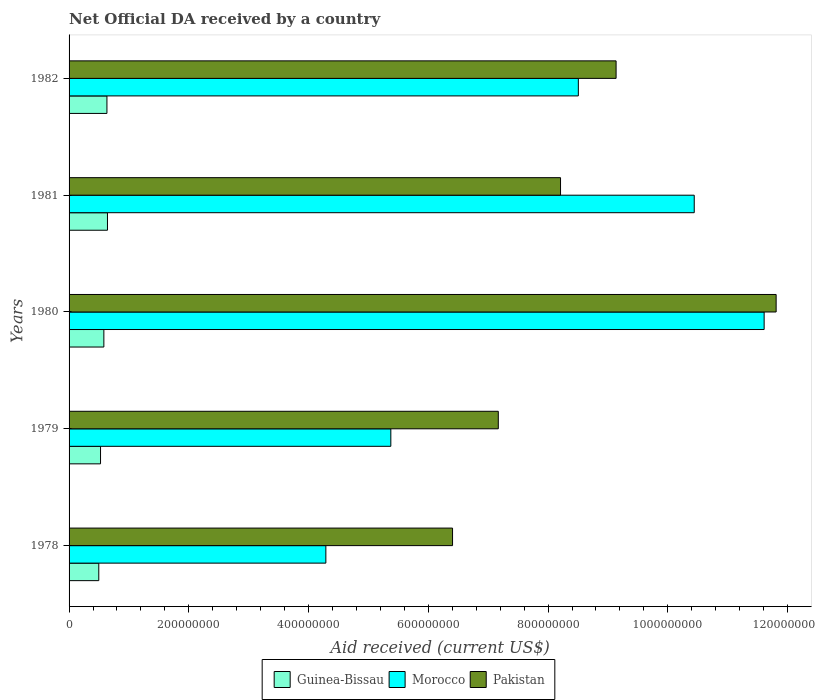How many groups of bars are there?
Your response must be concise. 5. What is the label of the 4th group of bars from the top?
Provide a short and direct response. 1979. In how many cases, is the number of bars for a given year not equal to the number of legend labels?
Make the answer very short. 0. What is the net official development assistance aid received in Guinea-Bissau in 1980?
Provide a succinct answer. 5.81e+07. Across all years, what is the maximum net official development assistance aid received in Guinea-Bissau?
Offer a terse response. 6.41e+07. Across all years, what is the minimum net official development assistance aid received in Morocco?
Provide a short and direct response. 4.29e+08. In which year was the net official development assistance aid received in Guinea-Bissau minimum?
Provide a succinct answer. 1978. What is the total net official development assistance aid received in Pakistan in the graph?
Offer a terse response. 4.27e+09. What is the difference between the net official development assistance aid received in Guinea-Bissau in 1979 and that in 1981?
Make the answer very short. -1.16e+07. What is the difference between the net official development assistance aid received in Pakistan in 1979 and the net official development assistance aid received in Morocco in 1980?
Provide a short and direct response. -4.44e+08. What is the average net official development assistance aid received in Pakistan per year?
Offer a terse response. 8.55e+08. In the year 1981, what is the difference between the net official development assistance aid received in Guinea-Bissau and net official development assistance aid received in Pakistan?
Your response must be concise. -7.57e+08. What is the ratio of the net official development assistance aid received in Morocco in 1978 to that in 1980?
Give a very brief answer. 0.37. Is the difference between the net official development assistance aid received in Guinea-Bissau in 1978 and 1979 greater than the difference between the net official development assistance aid received in Pakistan in 1978 and 1979?
Make the answer very short. Yes. What is the difference between the highest and the second highest net official development assistance aid received in Pakistan?
Keep it short and to the point. 2.67e+08. What is the difference between the highest and the lowest net official development assistance aid received in Guinea-Bissau?
Your answer should be compact. 1.45e+07. In how many years, is the net official development assistance aid received in Guinea-Bissau greater than the average net official development assistance aid received in Guinea-Bissau taken over all years?
Your answer should be very brief. 3. What does the 2nd bar from the top in 1979 represents?
Your response must be concise. Morocco. What does the 1st bar from the bottom in 1978 represents?
Offer a very short reply. Guinea-Bissau. Is it the case that in every year, the sum of the net official development assistance aid received in Morocco and net official development assistance aid received in Guinea-Bissau is greater than the net official development assistance aid received in Pakistan?
Keep it short and to the point. No. How many bars are there?
Give a very brief answer. 15. Are all the bars in the graph horizontal?
Ensure brevity in your answer.  Yes. How many years are there in the graph?
Give a very brief answer. 5. Are the values on the major ticks of X-axis written in scientific E-notation?
Ensure brevity in your answer.  No. Does the graph contain grids?
Offer a very short reply. No. How many legend labels are there?
Offer a very short reply. 3. How are the legend labels stacked?
Your response must be concise. Horizontal. What is the title of the graph?
Make the answer very short. Net Official DA received by a country. What is the label or title of the X-axis?
Make the answer very short. Aid received (current US$). What is the Aid received (current US$) of Guinea-Bissau in 1978?
Provide a succinct answer. 4.96e+07. What is the Aid received (current US$) in Morocco in 1978?
Provide a succinct answer. 4.29e+08. What is the Aid received (current US$) of Pakistan in 1978?
Make the answer very short. 6.40e+08. What is the Aid received (current US$) of Guinea-Bissau in 1979?
Ensure brevity in your answer.  5.25e+07. What is the Aid received (current US$) of Morocco in 1979?
Provide a succinct answer. 5.37e+08. What is the Aid received (current US$) of Pakistan in 1979?
Your answer should be compact. 7.17e+08. What is the Aid received (current US$) of Guinea-Bissau in 1980?
Your response must be concise. 5.81e+07. What is the Aid received (current US$) in Morocco in 1980?
Your answer should be very brief. 1.16e+09. What is the Aid received (current US$) of Pakistan in 1980?
Ensure brevity in your answer.  1.18e+09. What is the Aid received (current US$) in Guinea-Bissau in 1981?
Offer a terse response. 6.41e+07. What is the Aid received (current US$) in Morocco in 1981?
Make the answer very short. 1.04e+09. What is the Aid received (current US$) in Pakistan in 1981?
Provide a short and direct response. 8.21e+08. What is the Aid received (current US$) in Guinea-Bissau in 1982?
Provide a short and direct response. 6.32e+07. What is the Aid received (current US$) of Morocco in 1982?
Ensure brevity in your answer.  8.51e+08. What is the Aid received (current US$) of Pakistan in 1982?
Provide a short and direct response. 9.14e+08. Across all years, what is the maximum Aid received (current US$) in Guinea-Bissau?
Your response must be concise. 6.41e+07. Across all years, what is the maximum Aid received (current US$) in Morocco?
Provide a succinct answer. 1.16e+09. Across all years, what is the maximum Aid received (current US$) in Pakistan?
Offer a terse response. 1.18e+09. Across all years, what is the minimum Aid received (current US$) of Guinea-Bissau?
Your answer should be very brief. 4.96e+07. Across all years, what is the minimum Aid received (current US$) in Morocco?
Make the answer very short. 4.29e+08. Across all years, what is the minimum Aid received (current US$) of Pakistan?
Offer a terse response. 6.40e+08. What is the total Aid received (current US$) in Guinea-Bissau in the graph?
Give a very brief answer. 2.88e+08. What is the total Aid received (current US$) of Morocco in the graph?
Your response must be concise. 4.02e+09. What is the total Aid received (current US$) of Pakistan in the graph?
Your response must be concise. 4.27e+09. What is the difference between the Aid received (current US$) of Guinea-Bissau in 1978 and that in 1979?
Provide a succinct answer. -2.92e+06. What is the difference between the Aid received (current US$) in Morocco in 1978 and that in 1979?
Provide a short and direct response. -1.09e+08. What is the difference between the Aid received (current US$) of Pakistan in 1978 and that in 1979?
Your answer should be compact. -7.64e+07. What is the difference between the Aid received (current US$) of Guinea-Bissau in 1978 and that in 1980?
Provide a succinct answer. -8.49e+06. What is the difference between the Aid received (current US$) in Morocco in 1978 and that in 1980?
Your response must be concise. -7.32e+08. What is the difference between the Aid received (current US$) of Pakistan in 1978 and that in 1980?
Your response must be concise. -5.40e+08. What is the difference between the Aid received (current US$) of Guinea-Bissau in 1978 and that in 1981?
Give a very brief answer. -1.45e+07. What is the difference between the Aid received (current US$) in Morocco in 1978 and that in 1981?
Make the answer very short. -6.15e+08. What is the difference between the Aid received (current US$) in Pakistan in 1978 and that in 1981?
Your response must be concise. -1.80e+08. What is the difference between the Aid received (current US$) of Guinea-Bissau in 1978 and that in 1982?
Your answer should be very brief. -1.36e+07. What is the difference between the Aid received (current US$) in Morocco in 1978 and that in 1982?
Your response must be concise. -4.22e+08. What is the difference between the Aid received (current US$) of Pakistan in 1978 and that in 1982?
Ensure brevity in your answer.  -2.73e+08. What is the difference between the Aid received (current US$) of Guinea-Bissau in 1979 and that in 1980?
Your response must be concise. -5.57e+06. What is the difference between the Aid received (current US$) in Morocco in 1979 and that in 1980?
Your response must be concise. -6.23e+08. What is the difference between the Aid received (current US$) of Pakistan in 1979 and that in 1980?
Keep it short and to the point. -4.64e+08. What is the difference between the Aid received (current US$) in Guinea-Bissau in 1979 and that in 1981?
Ensure brevity in your answer.  -1.16e+07. What is the difference between the Aid received (current US$) in Morocco in 1979 and that in 1981?
Provide a succinct answer. -5.07e+08. What is the difference between the Aid received (current US$) of Pakistan in 1979 and that in 1981?
Keep it short and to the point. -1.04e+08. What is the difference between the Aid received (current US$) in Guinea-Bissau in 1979 and that in 1982?
Provide a succinct answer. -1.07e+07. What is the difference between the Aid received (current US$) in Morocco in 1979 and that in 1982?
Provide a short and direct response. -3.13e+08. What is the difference between the Aid received (current US$) in Pakistan in 1979 and that in 1982?
Provide a succinct answer. -1.97e+08. What is the difference between the Aid received (current US$) of Guinea-Bissau in 1980 and that in 1981?
Your answer should be compact. -6.02e+06. What is the difference between the Aid received (current US$) of Morocco in 1980 and that in 1981?
Your answer should be very brief. 1.17e+08. What is the difference between the Aid received (current US$) of Pakistan in 1980 and that in 1981?
Provide a succinct answer. 3.60e+08. What is the difference between the Aid received (current US$) in Guinea-Bissau in 1980 and that in 1982?
Make the answer very short. -5.13e+06. What is the difference between the Aid received (current US$) in Morocco in 1980 and that in 1982?
Ensure brevity in your answer.  3.10e+08. What is the difference between the Aid received (current US$) in Pakistan in 1980 and that in 1982?
Keep it short and to the point. 2.67e+08. What is the difference between the Aid received (current US$) of Guinea-Bissau in 1981 and that in 1982?
Your answer should be very brief. 8.90e+05. What is the difference between the Aid received (current US$) of Morocco in 1981 and that in 1982?
Your response must be concise. 1.94e+08. What is the difference between the Aid received (current US$) in Pakistan in 1981 and that in 1982?
Offer a terse response. -9.28e+07. What is the difference between the Aid received (current US$) of Guinea-Bissau in 1978 and the Aid received (current US$) of Morocco in 1979?
Your answer should be very brief. -4.88e+08. What is the difference between the Aid received (current US$) in Guinea-Bissau in 1978 and the Aid received (current US$) in Pakistan in 1979?
Provide a short and direct response. -6.67e+08. What is the difference between the Aid received (current US$) of Morocco in 1978 and the Aid received (current US$) of Pakistan in 1979?
Make the answer very short. -2.88e+08. What is the difference between the Aid received (current US$) of Guinea-Bissau in 1978 and the Aid received (current US$) of Morocco in 1980?
Make the answer very short. -1.11e+09. What is the difference between the Aid received (current US$) in Guinea-Bissau in 1978 and the Aid received (current US$) in Pakistan in 1980?
Your answer should be very brief. -1.13e+09. What is the difference between the Aid received (current US$) of Morocco in 1978 and the Aid received (current US$) of Pakistan in 1980?
Provide a short and direct response. -7.52e+08. What is the difference between the Aid received (current US$) in Guinea-Bissau in 1978 and the Aid received (current US$) in Morocco in 1981?
Offer a very short reply. -9.94e+08. What is the difference between the Aid received (current US$) of Guinea-Bissau in 1978 and the Aid received (current US$) of Pakistan in 1981?
Your answer should be compact. -7.71e+08. What is the difference between the Aid received (current US$) in Morocco in 1978 and the Aid received (current US$) in Pakistan in 1981?
Make the answer very short. -3.92e+08. What is the difference between the Aid received (current US$) in Guinea-Bissau in 1978 and the Aid received (current US$) in Morocco in 1982?
Offer a very short reply. -8.01e+08. What is the difference between the Aid received (current US$) in Guinea-Bissau in 1978 and the Aid received (current US$) in Pakistan in 1982?
Provide a short and direct response. -8.64e+08. What is the difference between the Aid received (current US$) of Morocco in 1978 and the Aid received (current US$) of Pakistan in 1982?
Your response must be concise. -4.85e+08. What is the difference between the Aid received (current US$) of Guinea-Bissau in 1979 and the Aid received (current US$) of Morocco in 1980?
Your response must be concise. -1.11e+09. What is the difference between the Aid received (current US$) in Guinea-Bissau in 1979 and the Aid received (current US$) in Pakistan in 1980?
Give a very brief answer. -1.13e+09. What is the difference between the Aid received (current US$) in Morocco in 1979 and the Aid received (current US$) in Pakistan in 1980?
Offer a very short reply. -6.44e+08. What is the difference between the Aid received (current US$) of Guinea-Bissau in 1979 and the Aid received (current US$) of Morocco in 1981?
Offer a very short reply. -9.92e+08. What is the difference between the Aid received (current US$) in Guinea-Bissau in 1979 and the Aid received (current US$) in Pakistan in 1981?
Offer a very short reply. -7.68e+08. What is the difference between the Aid received (current US$) in Morocco in 1979 and the Aid received (current US$) in Pakistan in 1981?
Your answer should be compact. -2.83e+08. What is the difference between the Aid received (current US$) in Guinea-Bissau in 1979 and the Aid received (current US$) in Morocco in 1982?
Your answer should be very brief. -7.98e+08. What is the difference between the Aid received (current US$) in Guinea-Bissau in 1979 and the Aid received (current US$) in Pakistan in 1982?
Your answer should be compact. -8.61e+08. What is the difference between the Aid received (current US$) of Morocco in 1979 and the Aid received (current US$) of Pakistan in 1982?
Give a very brief answer. -3.76e+08. What is the difference between the Aid received (current US$) in Guinea-Bissau in 1980 and the Aid received (current US$) in Morocco in 1981?
Your response must be concise. -9.86e+08. What is the difference between the Aid received (current US$) in Guinea-Bissau in 1980 and the Aid received (current US$) in Pakistan in 1981?
Give a very brief answer. -7.63e+08. What is the difference between the Aid received (current US$) of Morocco in 1980 and the Aid received (current US$) of Pakistan in 1981?
Keep it short and to the point. 3.40e+08. What is the difference between the Aid received (current US$) in Guinea-Bissau in 1980 and the Aid received (current US$) in Morocco in 1982?
Provide a succinct answer. -7.92e+08. What is the difference between the Aid received (current US$) of Guinea-Bissau in 1980 and the Aid received (current US$) of Pakistan in 1982?
Offer a terse response. -8.55e+08. What is the difference between the Aid received (current US$) in Morocco in 1980 and the Aid received (current US$) in Pakistan in 1982?
Provide a short and direct response. 2.47e+08. What is the difference between the Aid received (current US$) in Guinea-Bissau in 1981 and the Aid received (current US$) in Morocco in 1982?
Provide a short and direct response. -7.86e+08. What is the difference between the Aid received (current US$) of Guinea-Bissau in 1981 and the Aid received (current US$) of Pakistan in 1982?
Offer a very short reply. -8.49e+08. What is the difference between the Aid received (current US$) of Morocco in 1981 and the Aid received (current US$) of Pakistan in 1982?
Give a very brief answer. 1.31e+08. What is the average Aid received (current US$) in Guinea-Bissau per year?
Provide a succinct answer. 5.75e+07. What is the average Aid received (current US$) in Morocco per year?
Keep it short and to the point. 8.04e+08. What is the average Aid received (current US$) of Pakistan per year?
Make the answer very short. 8.55e+08. In the year 1978, what is the difference between the Aid received (current US$) of Guinea-Bissau and Aid received (current US$) of Morocco?
Provide a succinct answer. -3.79e+08. In the year 1978, what is the difference between the Aid received (current US$) of Guinea-Bissau and Aid received (current US$) of Pakistan?
Keep it short and to the point. -5.91e+08. In the year 1978, what is the difference between the Aid received (current US$) of Morocco and Aid received (current US$) of Pakistan?
Keep it short and to the point. -2.12e+08. In the year 1979, what is the difference between the Aid received (current US$) of Guinea-Bissau and Aid received (current US$) of Morocco?
Provide a short and direct response. -4.85e+08. In the year 1979, what is the difference between the Aid received (current US$) of Guinea-Bissau and Aid received (current US$) of Pakistan?
Offer a very short reply. -6.64e+08. In the year 1979, what is the difference between the Aid received (current US$) in Morocco and Aid received (current US$) in Pakistan?
Offer a terse response. -1.79e+08. In the year 1980, what is the difference between the Aid received (current US$) of Guinea-Bissau and Aid received (current US$) of Morocco?
Your answer should be compact. -1.10e+09. In the year 1980, what is the difference between the Aid received (current US$) of Guinea-Bissau and Aid received (current US$) of Pakistan?
Ensure brevity in your answer.  -1.12e+09. In the year 1980, what is the difference between the Aid received (current US$) in Morocco and Aid received (current US$) in Pakistan?
Keep it short and to the point. -2.00e+07. In the year 1981, what is the difference between the Aid received (current US$) in Guinea-Bissau and Aid received (current US$) in Morocco?
Your response must be concise. -9.80e+08. In the year 1981, what is the difference between the Aid received (current US$) of Guinea-Bissau and Aid received (current US$) of Pakistan?
Your answer should be very brief. -7.57e+08. In the year 1981, what is the difference between the Aid received (current US$) of Morocco and Aid received (current US$) of Pakistan?
Make the answer very short. 2.23e+08. In the year 1982, what is the difference between the Aid received (current US$) in Guinea-Bissau and Aid received (current US$) in Morocco?
Offer a very short reply. -7.87e+08. In the year 1982, what is the difference between the Aid received (current US$) of Guinea-Bissau and Aid received (current US$) of Pakistan?
Your answer should be compact. -8.50e+08. In the year 1982, what is the difference between the Aid received (current US$) in Morocco and Aid received (current US$) in Pakistan?
Make the answer very short. -6.30e+07. What is the ratio of the Aid received (current US$) in Guinea-Bissau in 1978 to that in 1979?
Make the answer very short. 0.94. What is the ratio of the Aid received (current US$) in Morocco in 1978 to that in 1979?
Give a very brief answer. 0.8. What is the ratio of the Aid received (current US$) in Pakistan in 1978 to that in 1979?
Make the answer very short. 0.89. What is the ratio of the Aid received (current US$) of Guinea-Bissau in 1978 to that in 1980?
Your answer should be compact. 0.85. What is the ratio of the Aid received (current US$) in Morocco in 1978 to that in 1980?
Give a very brief answer. 0.37. What is the ratio of the Aid received (current US$) of Pakistan in 1978 to that in 1980?
Make the answer very short. 0.54. What is the ratio of the Aid received (current US$) in Guinea-Bissau in 1978 to that in 1981?
Keep it short and to the point. 0.77. What is the ratio of the Aid received (current US$) of Morocco in 1978 to that in 1981?
Your response must be concise. 0.41. What is the ratio of the Aid received (current US$) of Pakistan in 1978 to that in 1981?
Your answer should be very brief. 0.78. What is the ratio of the Aid received (current US$) in Guinea-Bissau in 1978 to that in 1982?
Provide a short and direct response. 0.78. What is the ratio of the Aid received (current US$) in Morocco in 1978 to that in 1982?
Provide a short and direct response. 0.5. What is the ratio of the Aid received (current US$) of Pakistan in 1978 to that in 1982?
Make the answer very short. 0.7. What is the ratio of the Aid received (current US$) in Guinea-Bissau in 1979 to that in 1980?
Your answer should be compact. 0.9. What is the ratio of the Aid received (current US$) of Morocco in 1979 to that in 1980?
Provide a succinct answer. 0.46. What is the ratio of the Aid received (current US$) of Pakistan in 1979 to that in 1980?
Your answer should be very brief. 0.61. What is the ratio of the Aid received (current US$) in Guinea-Bissau in 1979 to that in 1981?
Offer a very short reply. 0.82. What is the ratio of the Aid received (current US$) in Morocco in 1979 to that in 1981?
Your answer should be very brief. 0.51. What is the ratio of the Aid received (current US$) in Pakistan in 1979 to that in 1981?
Offer a very short reply. 0.87. What is the ratio of the Aid received (current US$) in Guinea-Bissau in 1979 to that in 1982?
Offer a terse response. 0.83. What is the ratio of the Aid received (current US$) of Morocco in 1979 to that in 1982?
Provide a succinct answer. 0.63. What is the ratio of the Aid received (current US$) of Pakistan in 1979 to that in 1982?
Offer a very short reply. 0.78. What is the ratio of the Aid received (current US$) in Guinea-Bissau in 1980 to that in 1981?
Offer a terse response. 0.91. What is the ratio of the Aid received (current US$) of Morocco in 1980 to that in 1981?
Give a very brief answer. 1.11. What is the ratio of the Aid received (current US$) of Pakistan in 1980 to that in 1981?
Ensure brevity in your answer.  1.44. What is the ratio of the Aid received (current US$) in Guinea-Bissau in 1980 to that in 1982?
Make the answer very short. 0.92. What is the ratio of the Aid received (current US$) in Morocco in 1980 to that in 1982?
Offer a terse response. 1.36. What is the ratio of the Aid received (current US$) of Pakistan in 1980 to that in 1982?
Offer a very short reply. 1.29. What is the ratio of the Aid received (current US$) of Guinea-Bissau in 1981 to that in 1982?
Offer a very short reply. 1.01. What is the ratio of the Aid received (current US$) of Morocco in 1981 to that in 1982?
Your answer should be compact. 1.23. What is the ratio of the Aid received (current US$) of Pakistan in 1981 to that in 1982?
Your answer should be very brief. 0.9. What is the difference between the highest and the second highest Aid received (current US$) in Guinea-Bissau?
Keep it short and to the point. 8.90e+05. What is the difference between the highest and the second highest Aid received (current US$) of Morocco?
Keep it short and to the point. 1.17e+08. What is the difference between the highest and the second highest Aid received (current US$) of Pakistan?
Offer a terse response. 2.67e+08. What is the difference between the highest and the lowest Aid received (current US$) of Guinea-Bissau?
Provide a succinct answer. 1.45e+07. What is the difference between the highest and the lowest Aid received (current US$) in Morocco?
Make the answer very short. 7.32e+08. What is the difference between the highest and the lowest Aid received (current US$) in Pakistan?
Offer a terse response. 5.40e+08. 